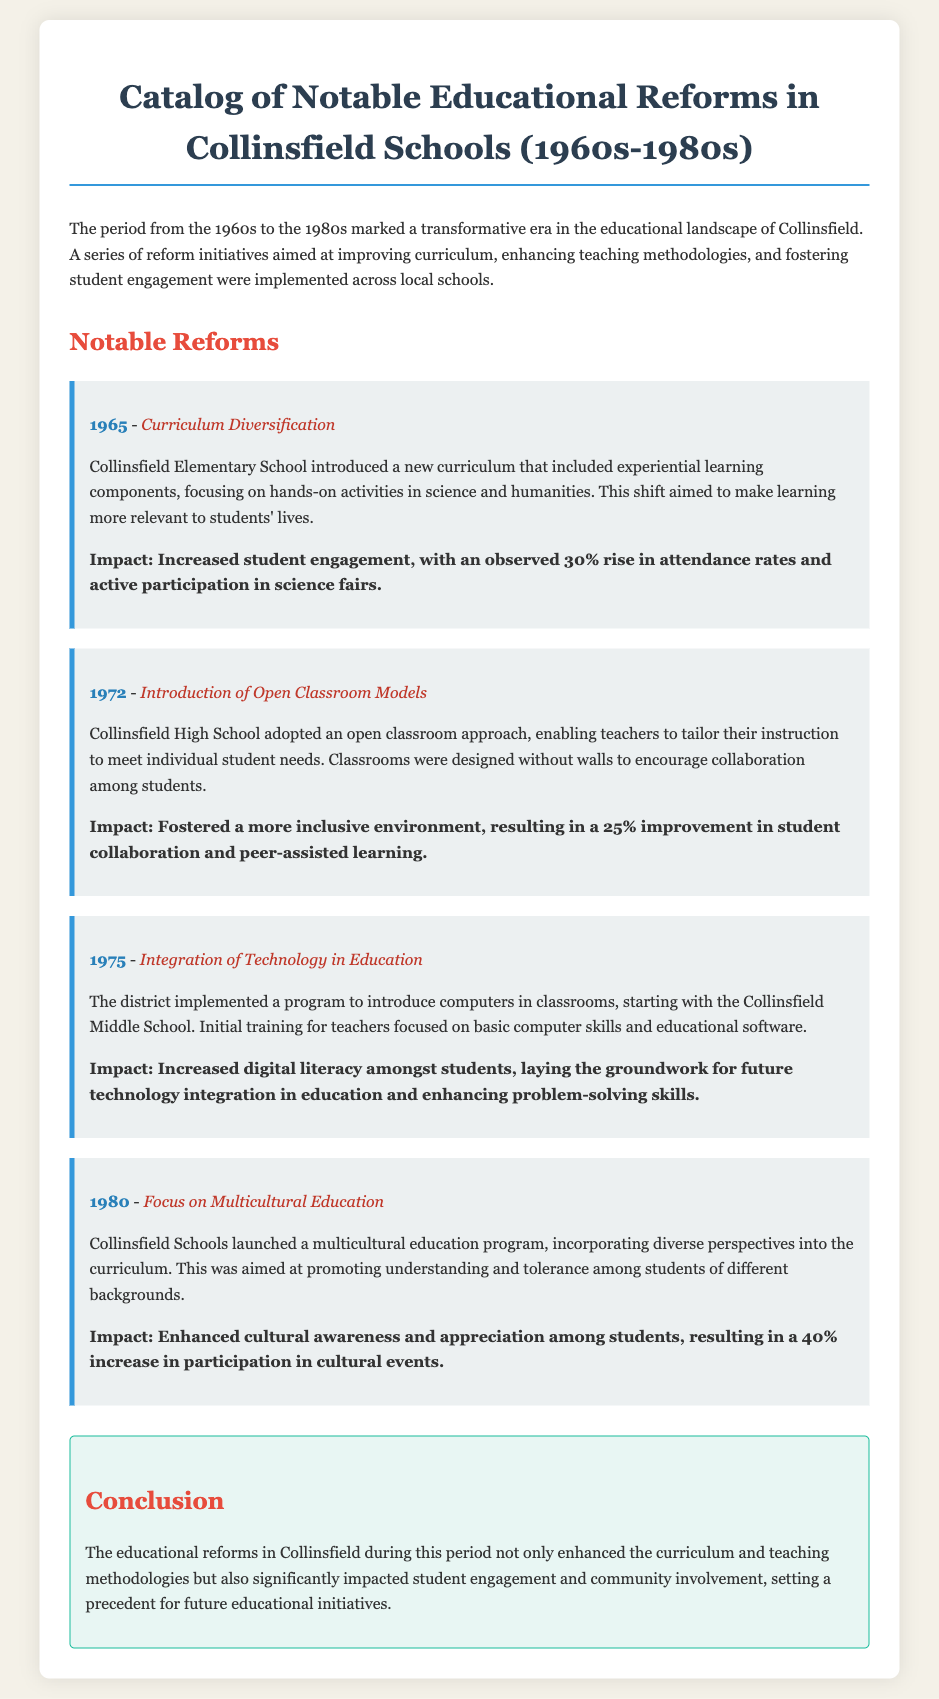What year was curriculum diversification introduced? The document states that curriculum diversification was introduced in 1965 at Collinsfield Elementary School.
Answer: 1965 What percentage increase in attendance rates was observed with the curriculum changes? The impact of curriculum diversification was a 30% rise in attendance rates.
Answer: 30% What teaching model was introduced at Collinsfield High School in 1972? The document mentions the introduction of an open classroom model in 1972 at Collinsfield High School.
Answer: Open classroom models Which school first implemented technology integration in 1975? The integration of technology began at Collinsfield Middle School in 1975.
Answer: Collinsfield Middle School What was the focus of the educational reform in 1980? In 1980, the focus of the reform was on multicultural education.
Answer: Multicultural education How much did student collaboration improve due to the open classroom model? The introduction of the open classroom model led to a 25% improvement in student collaboration.
Answer: 25% What impact did the multicultural education program have on cultural event participation? The program resulted in a 40% increase in participation in cultural events among students.
Answer: 40% What type of learning components were introduced in the 1965 curriculum reform? The curriculum diversification included experiential learning components focusing on hands-on activities.
Answer: Experiential learning components What was one outcome of integrating technology into education? One outcome was increased digital literacy among students, enhancing problem-solving skills.
Answer: Increased digital literacy 